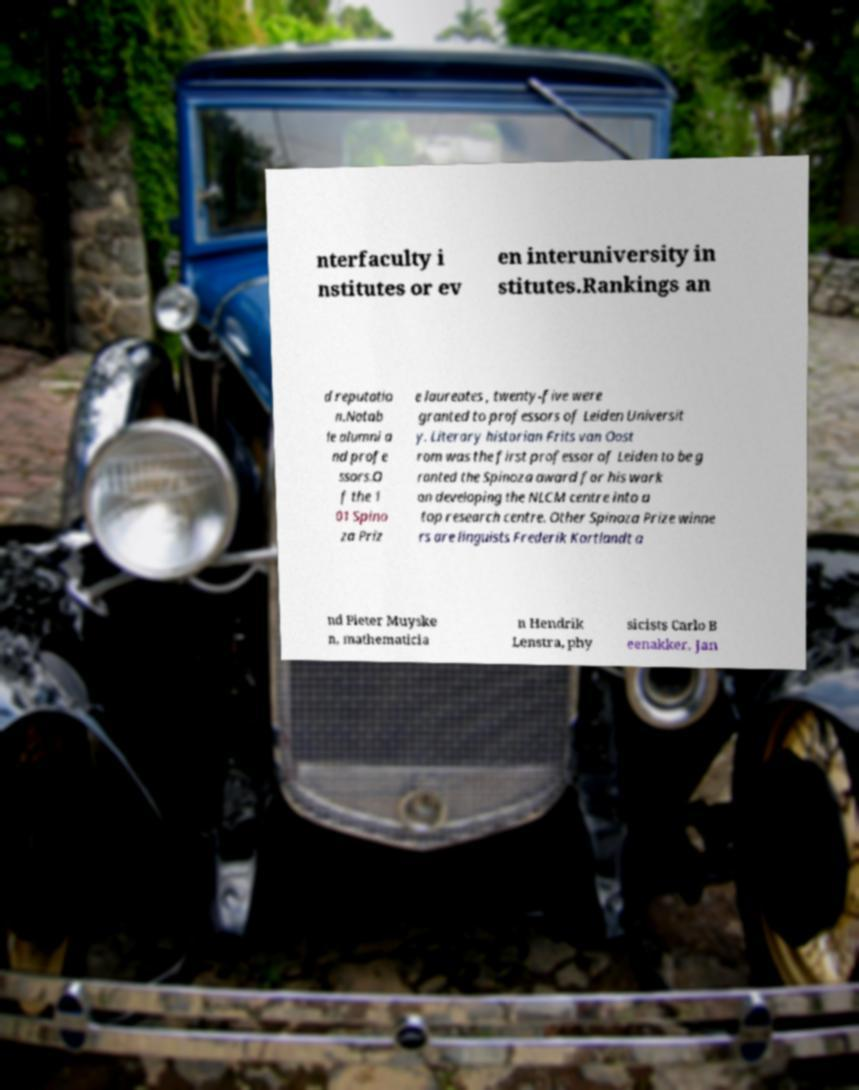Can you accurately transcribe the text from the provided image for me? nterfaculty i nstitutes or ev en interuniversity in stitutes.Rankings an d reputatio n.Notab le alumni a nd profe ssors.O f the 1 01 Spino za Priz e laureates , twenty-five were granted to professors of Leiden Universit y. Literary historian Frits van Oost rom was the first professor of Leiden to be g ranted the Spinoza award for his work on developing the NLCM centre into a top research centre. Other Spinoza Prize winne rs are linguists Frederik Kortlandt a nd Pieter Muyske n, mathematicia n Hendrik Lenstra, phy sicists Carlo B eenakker, Jan 